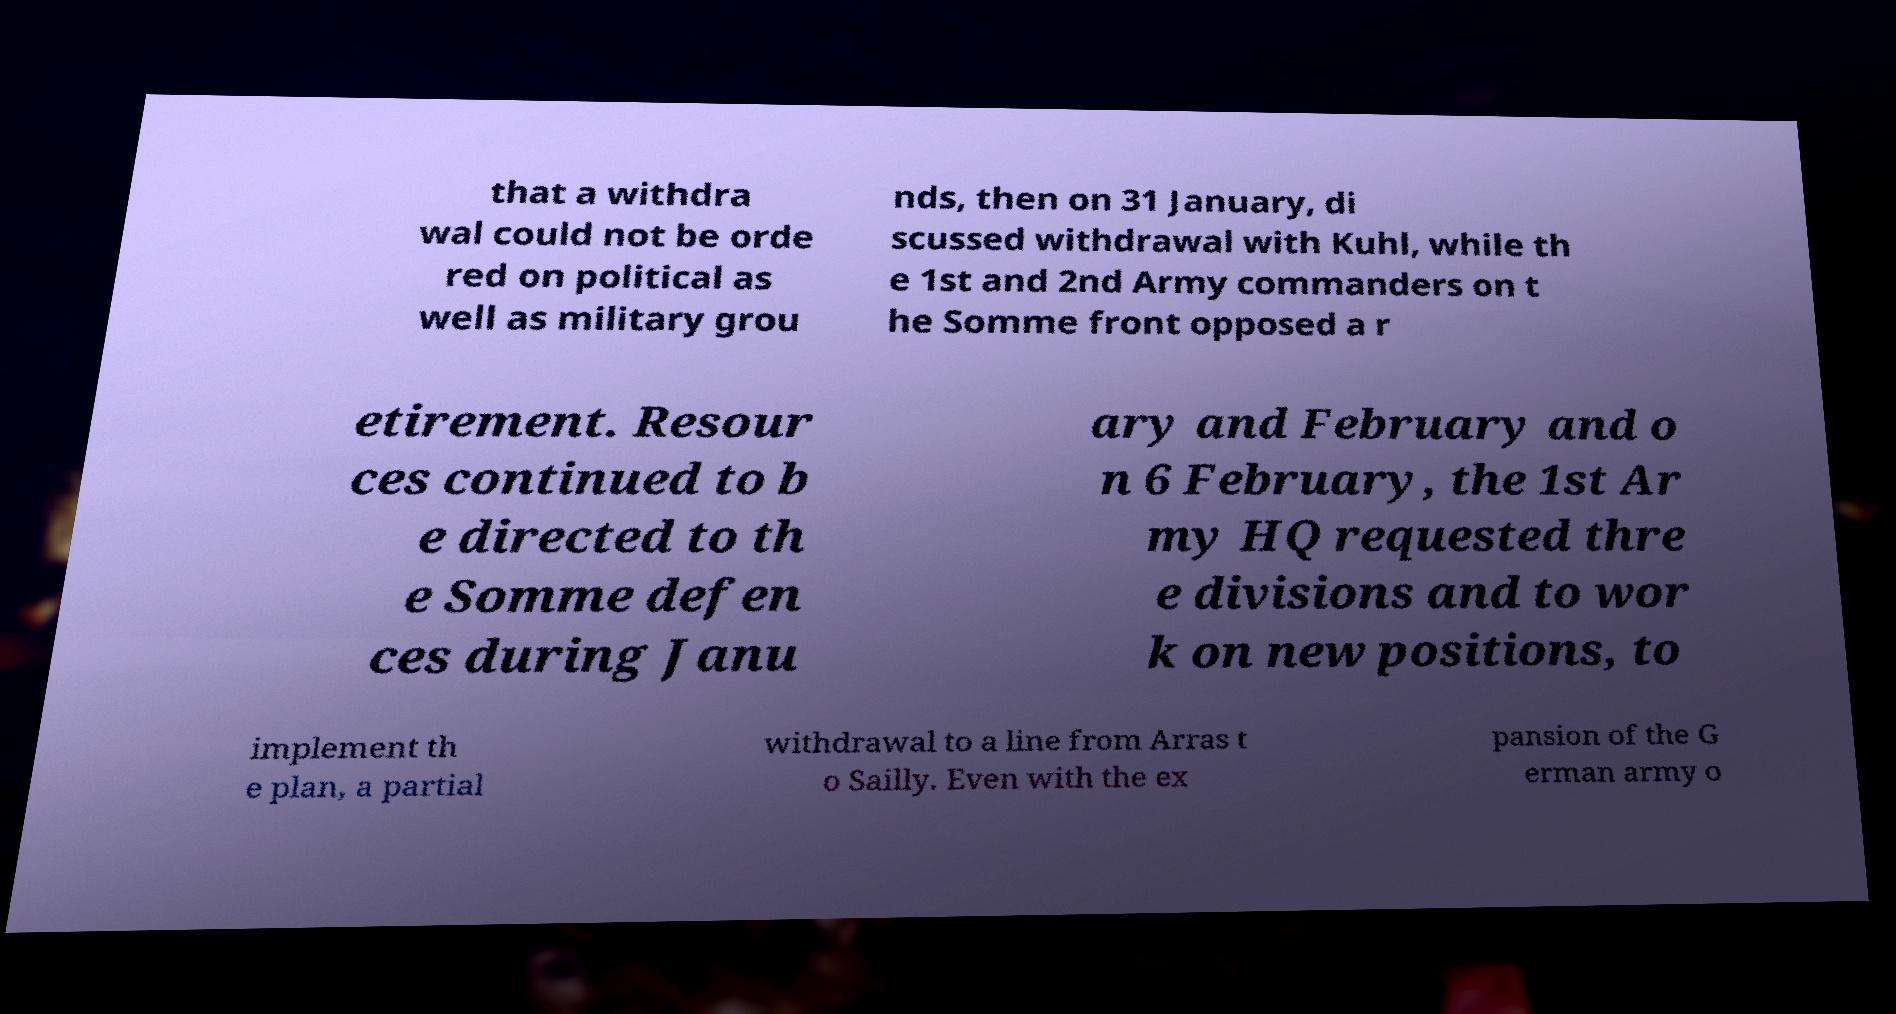Please read and relay the text visible in this image. What does it say? that a withdra wal could not be orde red on political as well as military grou nds, then on 31 January, di scussed withdrawal with Kuhl, while th e 1st and 2nd Army commanders on t he Somme front opposed a r etirement. Resour ces continued to b e directed to th e Somme defen ces during Janu ary and February and o n 6 February, the 1st Ar my HQ requested thre e divisions and to wor k on new positions, to implement th e plan, a partial withdrawal to a line from Arras t o Sailly. Even with the ex pansion of the G erman army o 